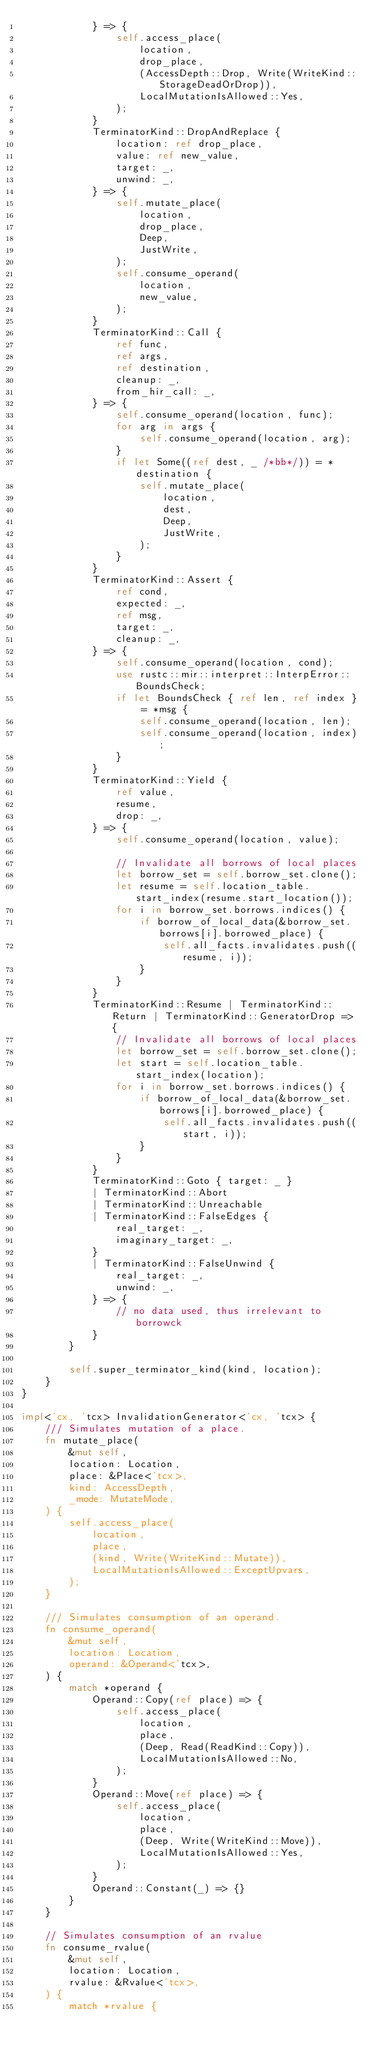<code> <loc_0><loc_0><loc_500><loc_500><_Rust_>            } => {
                self.access_place(
                    location,
                    drop_place,
                    (AccessDepth::Drop, Write(WriteKind::StorageDeadOrDrop)),
                    LocalMutationIsAllowed::Yes,
                );
            }
            TerminatorKind::DropAndReplace {
                location: ref drop_place,
                value: ref new_value,
                target: _,
                unwind: _,
            } => {
                self.mutate_place(
                    location,
                    drop_place,
                    Deep,
                    JustWrite,
                );
                self.consume_operand(
                    location,
                    new_value,
                );
            }
            TerminatorKind::Call {
                ref func,
                ref args,
                ref destination,
                cleanup: _,
                from_hir_call: _,
            } => {
                self.consume_operand(location, func);
                for arg in args {
                    self.consume_operand(location, arg);
                }
                if let Some((ref dest, _ /*bb*/)) = *destination {
                    self.mutate_place(
                        location,
                        dest,
                        Deep,
                        JustWrite,
                    );
                }
            }
            TerminatorKind::Assert {
                ref cond,
                expected: _,
                ref msg,
                target: _,
                cleanup: _,
            } => {
                self.consume_operand(location, cond);
                use rustc::mir::interpret::InterpError::BoundsCheck;
                if let BoundsCheck { ref len, ref index } = *msg {
                    self.consume_operand(location, len);
                    self.consume_operand(location, index);
                }
            }
            TerminatorKind::Yield {
                ref value,
                resume,
                drop: _,
            } => {
                self.consume_operand(location, value);

                // Invalidate all borrows of local places
                let borrow_set = self.borrow_set.clone();
                let resume = self.location_table.start_index(resume.start_location());
                for i in borrow_set.borrows.indices() {
                    if borrow_of_local_data(&borrow_set.borrows[i].borrowed_place) {
                        self.all_facts.invalidates.push((resume, i));
                    }
                }
            }
            TerminatorKind::Resume | TerminatorKind::Return | TerminatorKind::GeneratorDrop => {
                // Invalidate all borrows of local places
                let borrow_set = self.borrow_set.clone();
                let start = self.location_table.start_index(location);
                for i in borrow_set.borrows.indices() {
                    if borrow_of_local_data(&borrow_set.borrows[i].borrowed_place) {
                        self.all_facts.invalidates.push((start, i));
                    }
                }
            }
            TerminatorKind::Goto { target: _ }
            | TerminatorKind::Abort
            | TerminatorKind::Unreachable
            | TerminatorKind::FalseEdges {
                real_target: _,
                imaginary_target: _,
            }
            | TerminatorKind::FalseUnwind {
                real_target: _,
                unwind: _,
            } => {
                // no data used, thus irrelevant to borrowck
            }
        }

        self.super_terminator_kind(kind, location);
    }
}

impl<'cx, 'tcx> InvalidationGenerator<'cx, 'tcx> {
    /// Simulates mutation of a place.
    fn mutate_place(
        &mut self,
        location: Location,
        place: &Place<'tcx>,
        kind: AccessDepth,
        _mode: MutateMode,
    ) {
        self.access_place(
            location,
            place,
            (kind, Write(WriteKind::Mutate)),
            LocalMutationIsAllowed::ExceptUpvars,
        );
    }

    /// Simulates consumption of an operand.
    fn consume_operand(
        &mut self,
        location: Location,
        operand: &Operand<'tcx>,
    ) {
        match *operand {
            Operand::Copy(ref place) => {
                self.access_place(
                    location,
                    place,
                    (Deep, Read(ReadKind::Copy)),
                    LocalMutationIsAllowed::No,
                );
            }
            Operand::Move(ref place) => {
                self.access_place(
                    location,
                    place,
                    (Deep, Write(WriteKind::Move)),
                    LocalMutationIsAllowed::Yes,
                );
            }
            Operand::Constant(_) => {}
        }
    }

    // Simulates consumption of an rvalue
    fn consume_rvalue(
        &mut self,
        location: Location,
        rvalue: &Rvalue<'tcx>,
    ) {
        match *rvalue {</code> 